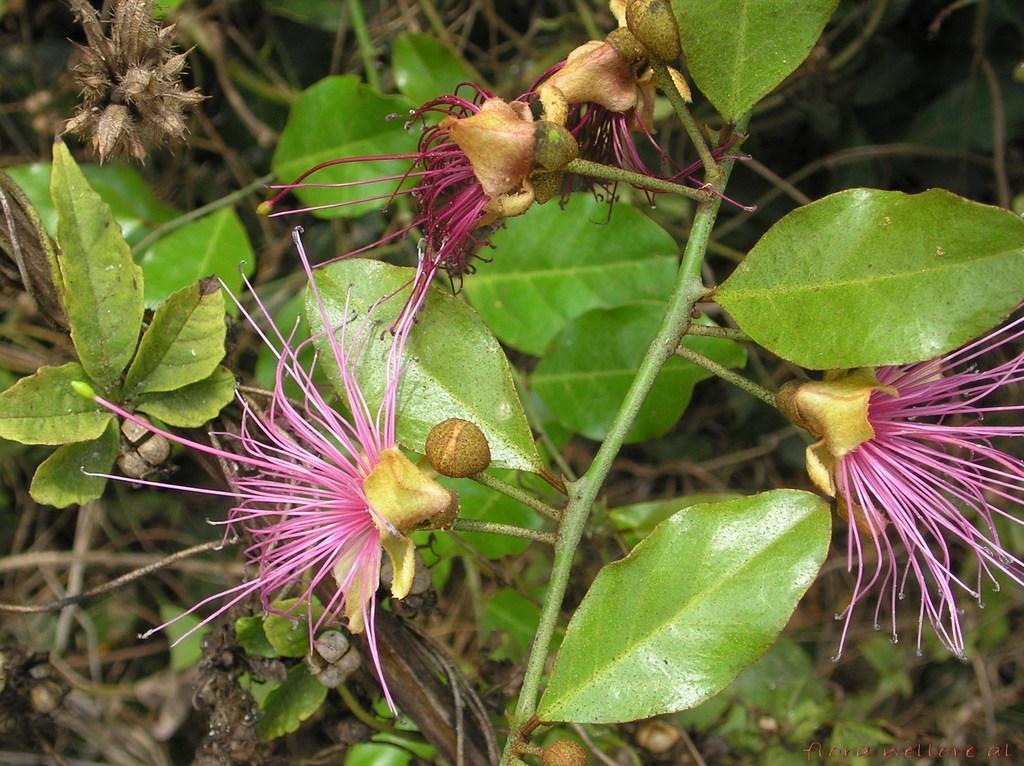Could you give a brief overview of what you see in this image? This image consists of a plant to which, we can see flowers and green leaves. 